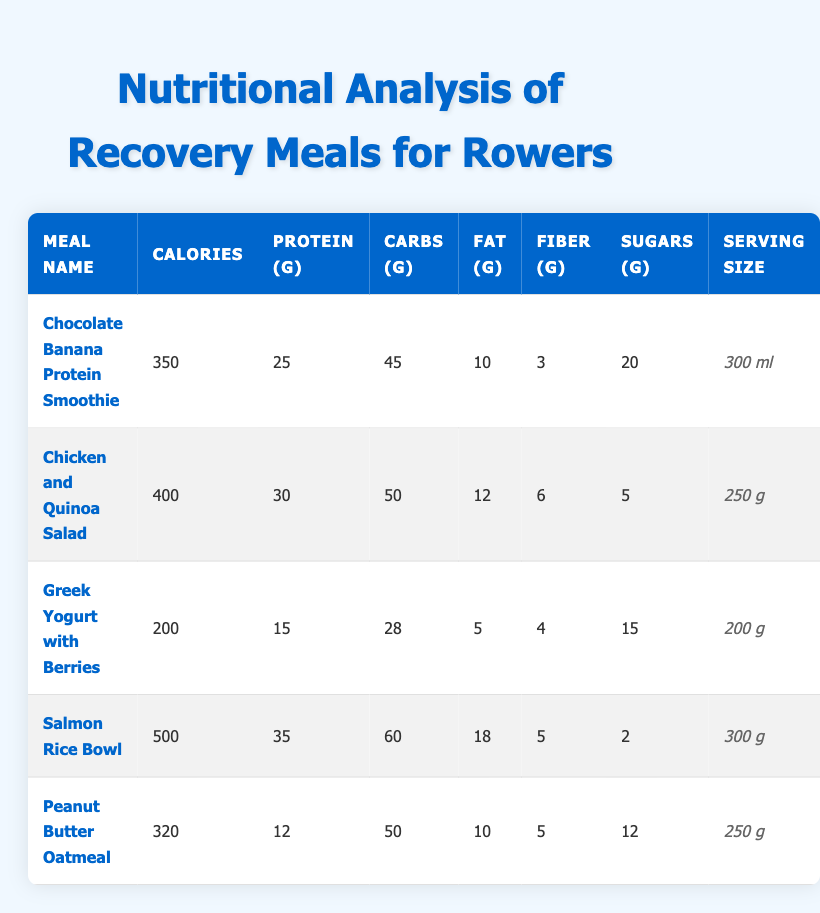What meal has the highest protein content? Looking at the "Protein (g)" column, the "Salmon Rice Bowl" has 35 grams of protein, which is higher than the other meals listed.
Answer: Salmon Rice Bowl Which meal contains the least sugar? The "Chicken and Quinoa Salad" has the least sugar with 5 grams, compared to other meals.
Answer: Chicken and Quinoa Salad What is the total calorie count of the "Chocolate Banana Protein Smoothie" and "Peanut Butter Oatmeal"? Adding the calories of both meals: 350 (Chocolate Banana Protein Smoothie) + 320 (Peanut Butter Oatmeal) = 670 calories.
Answer: 670 Is the "Greek Yogurt with Berries" more calorie-dense than the "Peanut Butter Oatmeal"? The calorie density is calculated by dividing total calories by serving size: Greek Yogurt (200 calories / 200g = 1) vs. Peanut Butter Oatmeal (320 calories / 250g = 1.28). Since 1.28 is greater, Peanut Butter Oatmeal is more calorie-dense.
Answer: No Which meal has the highest fat content and how much is it? The "Salmon Rice Bowl" has the highest fat content at 18 grams.
Answer: Salmon Rice Bowl, 18 g What is the average carbohydrate content across all the meals? First, sum the carbohydrate values: 45 + 50 + 28 + 60 + 50 = 233 grams. There are 5 meals, so the average is 233 / 5 = 46.6 grams.
Answer: 46.6 g Does the "Chicken and Quinoa Salad" provide more protein than the "Peanut Butter Oatmeal"? The "Chicken and Quinoa Salad" has 30 grams of protein while the "Peanut Butter Oatmeal" has 12 grams. Since 30 is greater than 12, the Chicken and Quinoa Salad provides more protein.
Answer: Yes How much more fiber does the "Chicken and Quinoa Salad" have compared to the "Greek Yogurt with Berries"? The Chicken and Quinoa Salad has 6 grams of fiber while the Greek Yogurt has 4 grams. The difference is 6 - 4 = 2 grams more fiber.
Answer: 2 g What is the total amount of carbohydrates in all meals combined? Add the carbohydrates: 45 + 50 + 28 + 60 + 50 = 233 grams total.
Answer: 233 g 